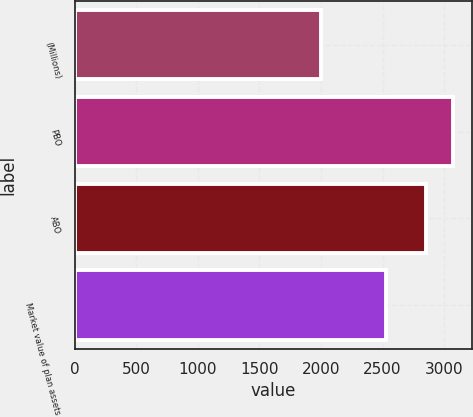Convert chart. <chart><loc_0><loc_0><loc_500><loc_500><bar_chart><fcel>(Millions)<fcel>PBO<fcel>ABO<fcel>Market value of plan assets<nl><fcel>2004<fcel>3074<fcel>2851<fcel>2532<nl></chart> 